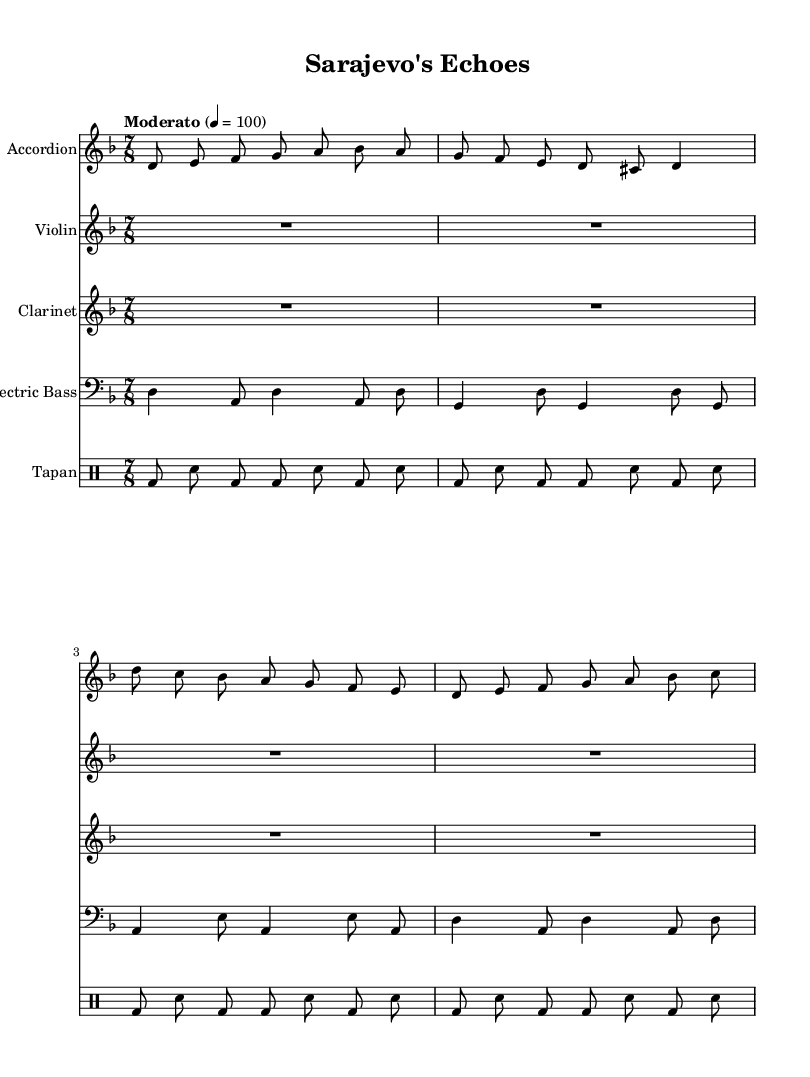What is the key signature of this music? The key signature is indicated at the beginning of the score. It shows one flat (B flat), which means the piece is in D minor.
Answer: D minor What is the time signature of this music? The time signature is displayed after the key signature at the beginning of the score. It is shown as 7/8, indicating there are seven beats per measure and the eighth note gets one beat.
Answer: 7/8 What is the tempo marking for this piece? The tempo marking is found in the score near the beginning, which indicates the speed of the music. It reads "Moderato" with a metronome marking of 4 = 100, suggesting a moderate pace.
Answer: Moderato How many instruments are featured in this score? The number of instruments can be counted by looking at the staff names in the score. There are five staves labeled Accordion, Violin, Clarinet, Electric Bass, and Tapan, which indicates five instruments.
Answer: 5 Which instrument has a rest in its part? The music for the Violin and Clarinet is written as "R1*7/8*4" which indicates a whole measure of rest. This is a common practice in ensemble pieces to allow certain instruments to join later.
Answer: Violin, Clarinet What type of rhythm does the tapan feature? By analyzing the rhythmic notation in the Tapan’s drum part, we see alternating bass drum and snare hits in a repetitive pattern, common for folk music. This creates a driving, dance-like feel typical in Balkan folk.
Answer: Folk rhythm What is the role of the electric bass in this piece? The electric bass plays a supportive harmonic role with a specific bass line comprised of quarter and eighth notes, which provides harmonic foundation and groove to the overall piece.
Answer: Harmonic foundation 